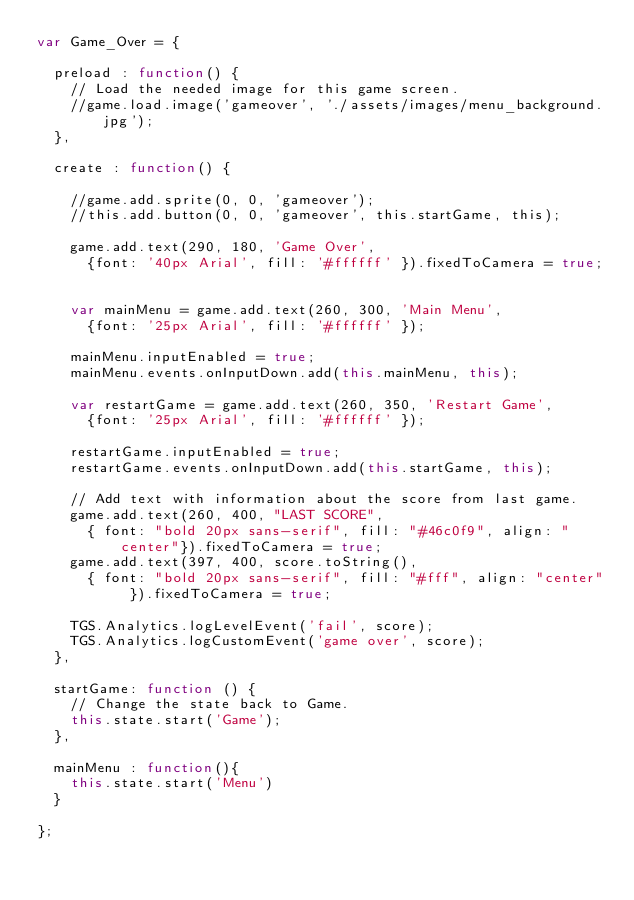Convert code to text. <code><loc_0><loc_0><loc_500><loc_500><_JavaScript_>var Game_Over = {

  preload : function() {
    // Load the needed image for this game screen.
    //game.load.image('gameover', './assets/images/menu_background.jpg');
  },

  create : function() {

    //game.add.sprite(0, 0, 'gameover');
    //this.add.button(0, 0, 'gameover', this.startGame, this);
        
    game.add.text(290, 180, 'Game Over', 
      {font: '40px Arial', fill: '#ffffff' }).fixedToCamera = true;


    var mainMenu = game.add.text(260, 300, 'Main Menu', 
      {font: '25px Arial', fill: '#ffffff' });

    mainMenu.inputEnabled = true;
    mainMenu.events.onInputDown.add(this.mainMenu, this);

    var restartGame = game.add.text(260, 350, 'Restart Game', 
      {font: '25px Arial', fill: '#ffffff' });

    restartGame.inputEnabled = true;
    restartGame.events.onInputDown.add(this.startGame, this);

    // Add text with information about the score from last game.
    game.add.text(260, 400, "LAST SCORE", 
      { font: "bold 20px sans-serif", fill: "#46c0f9", align: "center"}).fixedToCamera = true;
    game.add.text(397, 400, score.toString(),
      { font: "bold 20px sans-serif", fill: "#fff", align: "center" }).fixedToCamera = true;

    TGS.Analytics.logLevelEvent('fail', score);
    TGS.Analytics.logCustomEvent('game over', score);
  },

  startGame: function () {
    // Change the state back to Game.
    this.state.start('Game');
  },

  mainMenu : function(){
    this.state.start('Menu')
  }

};</code> 